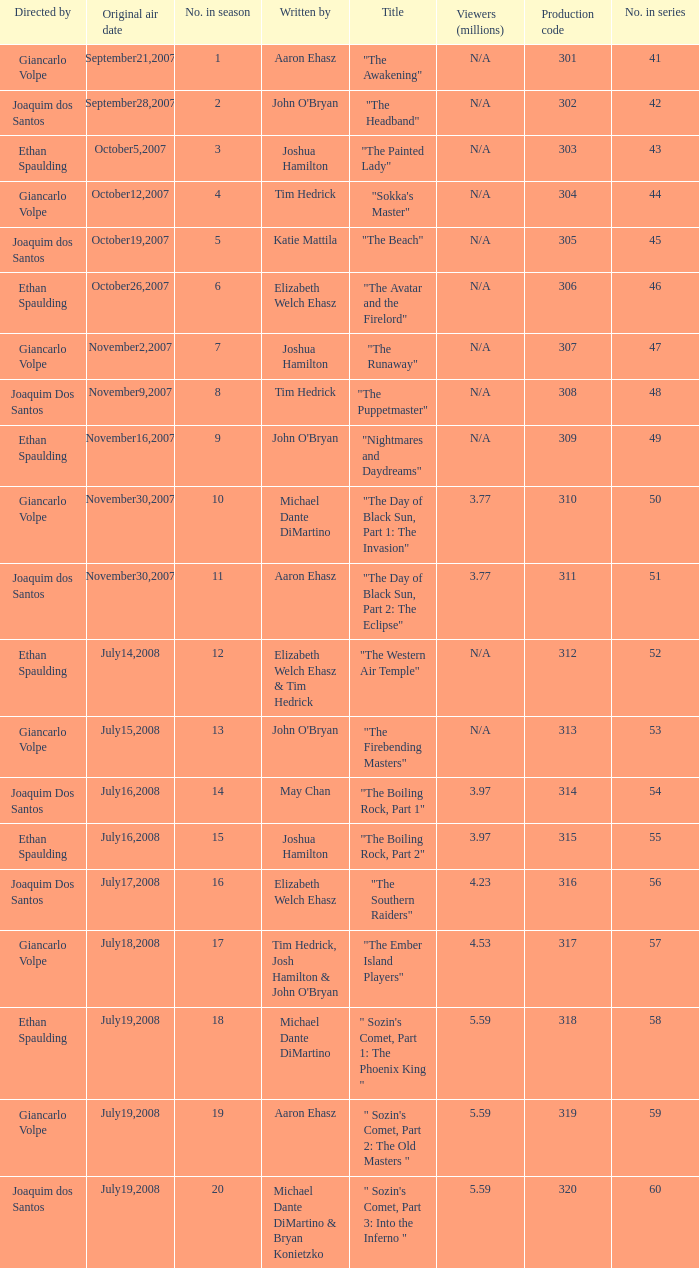How many viewers in millions for episode "sokka's master"? N/A. 